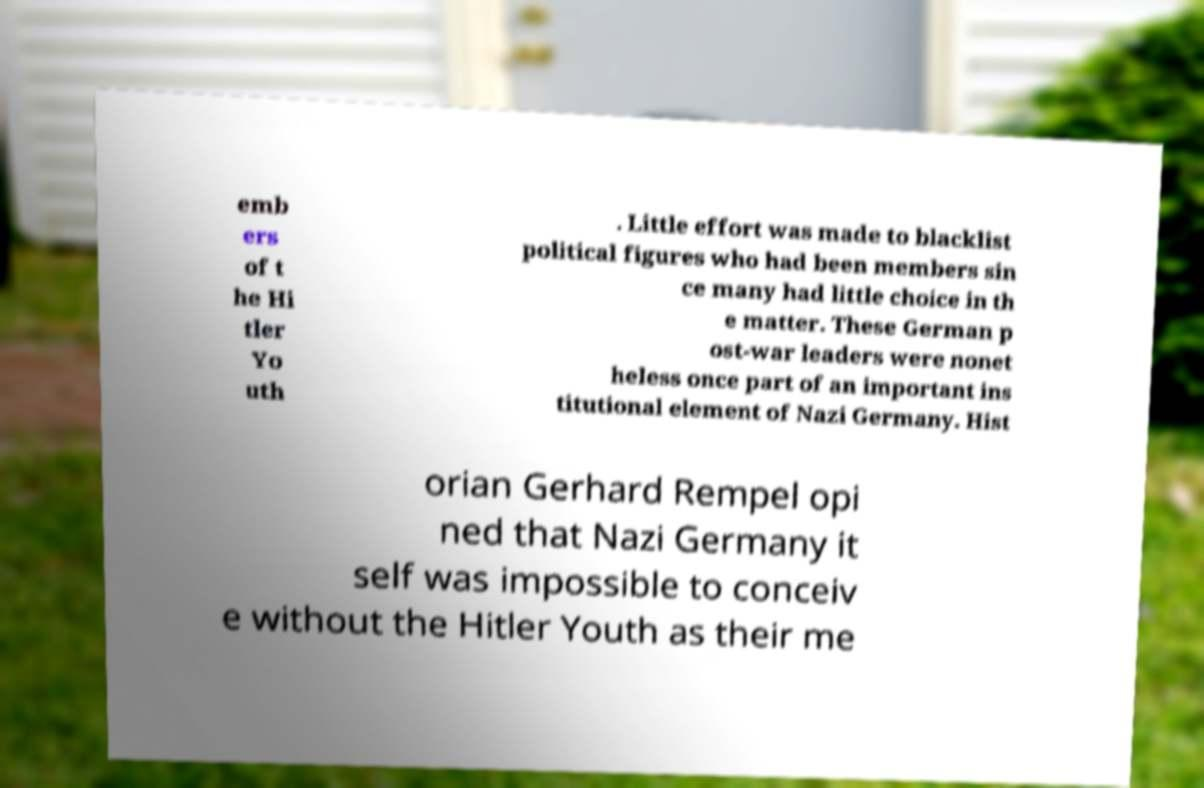Can you accurately transcribe the text from the provided image for me? emb ers of t he Hi tler Yo uth . Little effort was made to blacklist political figures who had been members sin ce many had little choice in th e matter. These German p ost-war leaders were nonet heless once part of an important ins titutional element of Nazi Germany. Hist orian Gerhard Rempel opi ned that Nazi Germany it self was impossible to conceiv e without the Hitler Youth as their me 